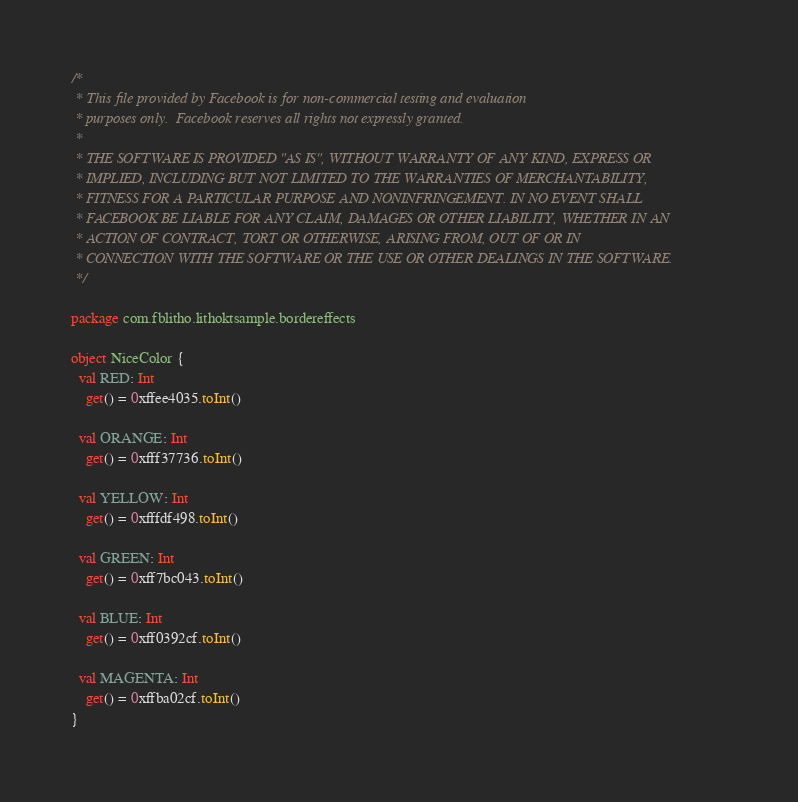Convert code to text. <code><loc_0><loc_0><loc_500><loc_500><_Kotlin_>/*
 * This file provided by Facebook is for non-commercial testing and evaluation
 * purposes only.  Facebook reserves all rights not expressly granted.
 *
 * THE SOFTWARE IS PROVIDED "AS IS", WITHOUT WARRANTY OF ANY KIND, EXPRESS OR
 * IMPLIED, INCLUDING BUT NOT LIMITED TO THE WARRANTIES OF MERCHANTABILITY,
 * FITNESS FOR A PARTICULAR PURPOSE AND NONINFRINGEMENT. IN NO EVENT SHALL
 * FACEBOOK BE LIABLE FOR ANY CLAIM, DAMAGES OR OTHER LIABILITY, WHETHER IN AN
 * ACTION OF CONTRACT, TORT OR OTHERWISE, ARISING FROM, OUT OF OR IN
 * CONNECTION WITH THE SOFTWARE OR THE USE OR OTHER DEALINGS IN THE SOFTWARE.
 */

package com.fblitho.lithoktsample.bordereffects

object NiceColor {
  val RED: Int
    get() = 0xffee4035.toInt()

  val ORANGE: Int
    get() = 0xfff37736.toInt()

  val YELLOW: Int
    get() = 0xfffdf498.toInt()

  val GREEN: Int
    get() = 0xff7bc043.toInt()

  val BLUE: Int
    get() = 0xff0392cf.toInt()

  val MAGENTA: Int
    get() = 0xffba02cf.toInt()
}
</code> 